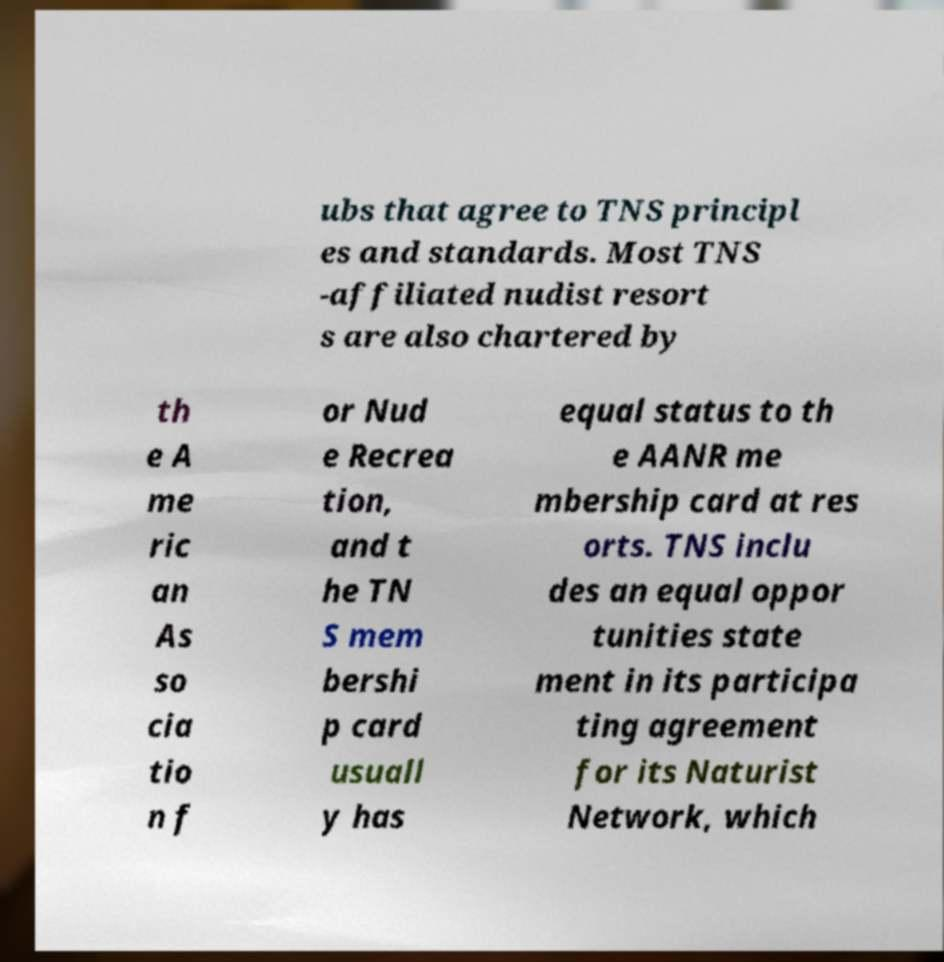Could you extract and type out the text from this image? ubs that agree to TNS principl es and standards. Most TNS -affiliated nudist resort s are also chartered by th e A me ric an As so cia tio n f or Nud e Recrea tion, and t he TN S mem bershi p card usuall y has equal status to th e AANR me mbership card at res orts. TNS inclu des an equal oppor tunities state ment in its participa ting agreement for its Naturist Network, which 